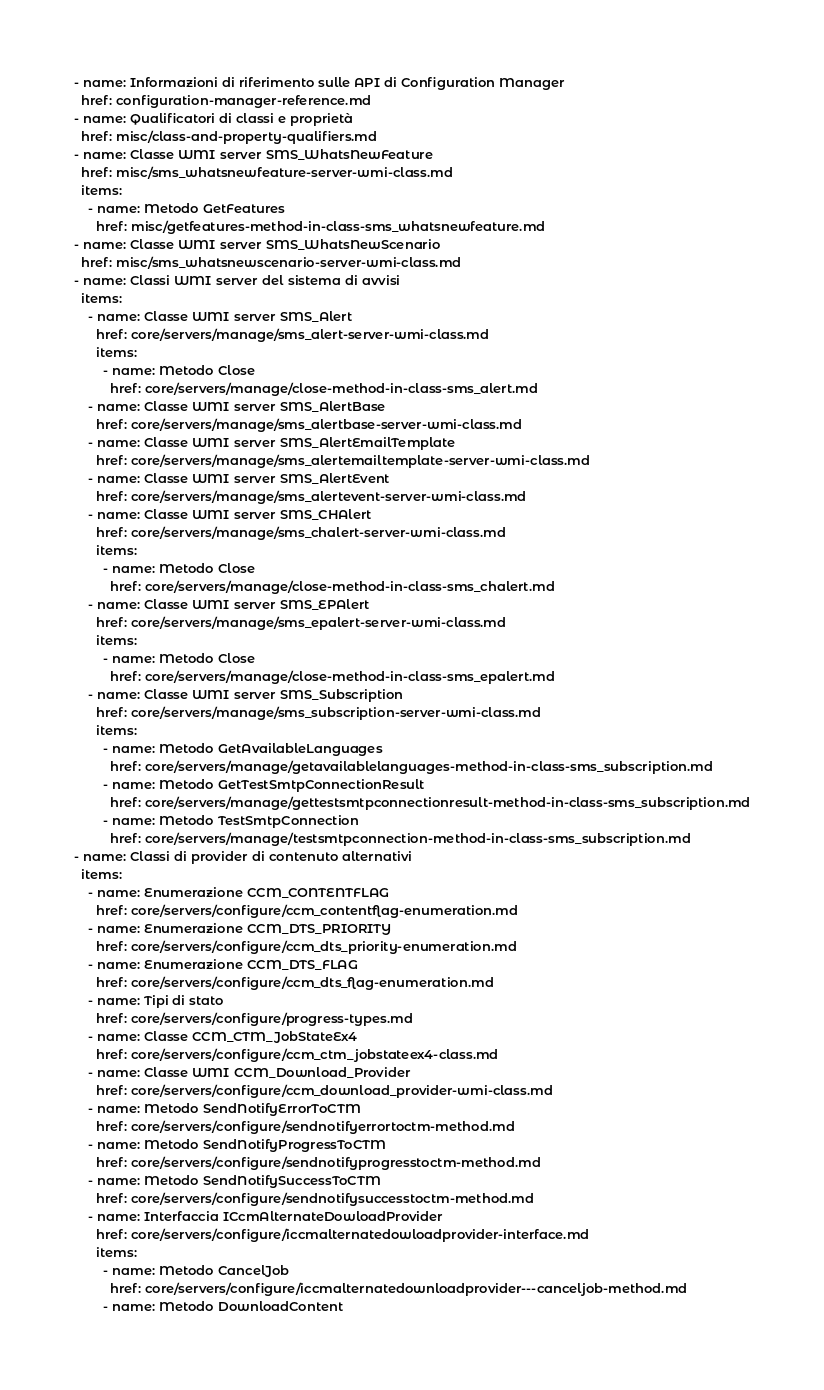Convert code to text. <code><loc_0><loc_0><loc_500><loc_500><_YAML_>- name: Informazioni di riferimento sulle API di Configuration Manager
  href: configuration-manager-reference.md
- name: Qualificatori di classi e proprietà
  href: misc/class-and-property-qualifiers.md
- name: Classe WMI server SMS_WhatsNewFeature
  href: misc/sms_whatsnewfeature-server-wmi-class.md
  items:
    - name: Metodo GetFeatures
      href: misc/getfeatures-method-in-class-sms_whatsnewfeature.md
- name: Classe WMI server SMS_WhatsNewScenario
  href: misc/sms_whatsnewscenario-server-wmi-class.md
- name: Classi WMI server del sistema di avvisi
  items:
    - name: Classe WMI server SMS_Alert
      href: core/servers/manage/sms_alert-server-wmi-class.md
      items:
        - name: Metodo Close
          href: core/servers/manage/close-method-in-class-sms_alert.md
    - name: Classe WMI server SMS_AlertBase
      href: core/servers/manage/sms_alertbase-server-wmi-class.md
    - name: Classe WMI server SMS_AlertEmailTemplate
      href: core/servers/manage/sms_alertemailtemplate-server-wmi-class.md
    - name: Classe WMI server SMS_AlertEvent
      href: core/servers/manage/sms_alertevent-server-wmi-class.md
    - name: Classe WMI server SMS_CHAlert
      href: core/servers/manage/sms_chalert-server-wmi-class.md
      items:
        - name: Metodo Close
          href: core/servers/manage/close-method-in-class-sms_chalert.md
    - name: Classe WMI server SMS_EPAlert
      href: core/servers/manage/sms_epalert-server-wmi-class.md
      items:
        - name: Metodo Close
          href: core/servers/manage/close-method-in-class-sms_epalert.md
    - name: Classe WMI server SMS_Subscription
      href: core/servers/manage/sms_subscription-server-wmi-class.md
      items:
        - name: Metodo GetAvailableLanguages
          href: core/servers/manage/getavailablelanguages-method-in-class-sms_subscription.md
        - name: Metodo GetTestSmtpConnectionResult
          href: core/servers/manage/gettestsmtpconnectionresult-method-in-class-sms_subscription.md
        - name: Metodo TestSmtpConnection
          href: core/servers/manage/testsmtpconnection-method-in-class-sms_subscription.md
- name: Classi di provider di contenuto alternativi
  items:
    - name: Enumerazione CCM_CONTENTFLAG
      href: core/servers/configure/ccm_contentflag-enumeration.md
    - name: Enumerazione CCM_DTS_PRIORITY
      href: core/servers/configure/ccm_dts_priority-enumeration.md
    - name: Enumerazione CCM_DTS_FLAG
      href: core/servers/configure/ccm_dts_flag-enumeration.md
    - name: Tipi di stato
      href: core/servers/configure/progress-types.md
    - name: Classe CCM_CTM_JobStateEx4
      href: core/servers/configure/ccm_ctm_jobstateex4-class.md
    - name: Classe WMI CCM_Download_Provider
      href: core/servers/configure/ccm_download_provider-wmi-class.md
    - name: Metodo SendNotifyErrorToCTM
      href: core/servers/configure/sendnotifyerrortoctm-method.md
    - name: Metodo SendNotifyProgressToCTM
      href: core/servers/configure/sendnotifyprogresstoctm-method.md
    - name: Metodo SendNotifySuccessToCTM
      href: core/servers/configure/sendnotifysuccesstoctm-method.md
    - name: Interfaccia ICcmAlternateDowloadProvider
      href: core/servers/configure/iccmalternatedowloadprovider-interface.md
      items:
        - name: Metodo CancelJob
          href: core/servers/configure/iccmalternatedownloadprovider---canceljob-method.md
        - name: Metodo DownloadContent</code> 